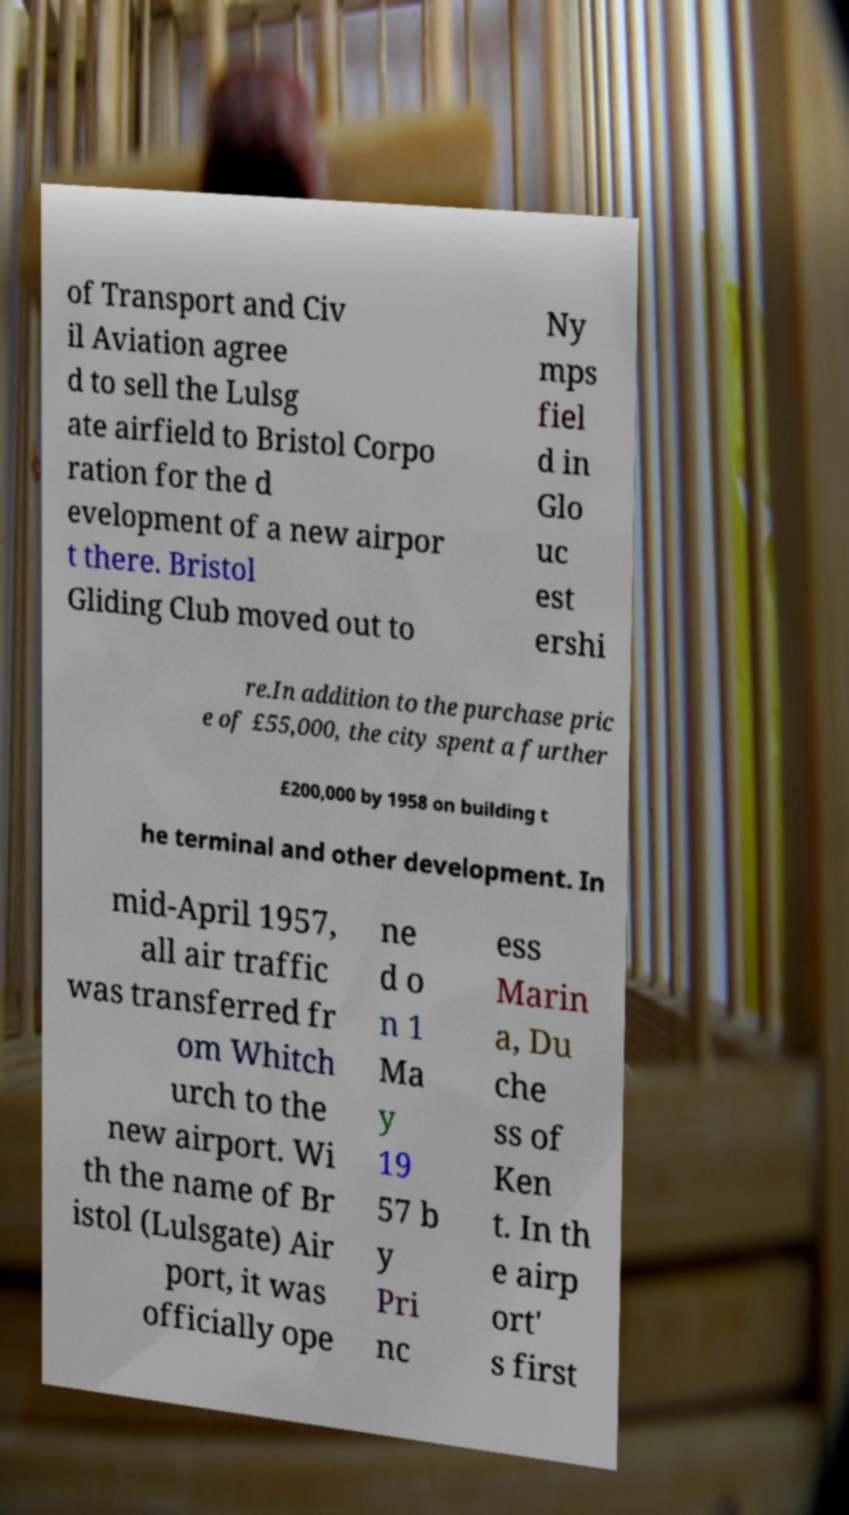For documentation purposes, I need the text within this image transcribed. Could you provide that? of Transport and Civ il Aviation agree d to sell the Lulsg ate airfield to Bristol Corpo ration for the d evelopment of a new airpor t there. Bristol Gliding Club moved out to Ny mps fiel d in Glo uc est ershi re.In addition to the purchase pric e of £55,000, the city spent a further £200,000 by 1958 on building t he terminal and other development. In mid-April 1957, all air traffic was transferred fr om Whitch urch to the new airport. Wi th the name of Br istol (Lulsgate) Air port, it was officially ope ne d o n 1 Ma y 19 57 b y Pri nc ess Marin a, Du che ss of Ken t. In th e airp ort' s first 